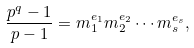Convert formula to latex. <formula><loc_0><loc_0><loc_500><loc_500>\frac { p ^ { q } - 1 } { p - 1 } = m _ { 1 } ^ { e _ { 1 } } m _ { 2 } ^ { e _ { 2 } } \cdots m _ { s } ^ { e _ { s } } ,</formula> 